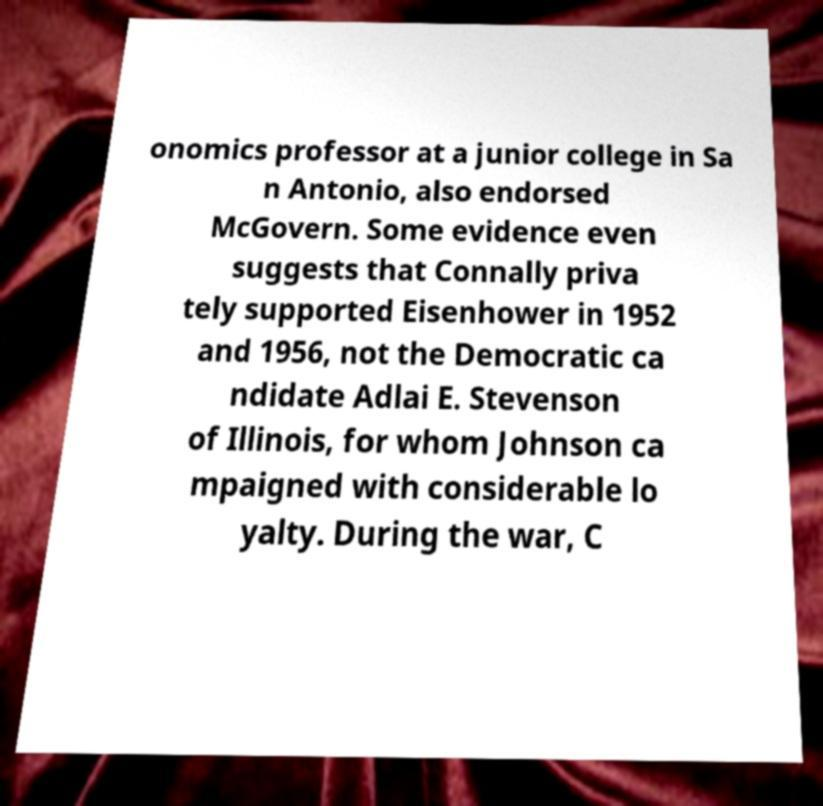Could you extract and type out the text from this image? onomics professor at a junior college in Sa n Antonio, also endorsed McGovern. Some evidence even suggests that Connally priva tely supported Eisenhower in 1952 and 1956, not the Democratic ca ndidate Adlai E. Stevenson of Illinois, for whom Johnson ca mpaigned with considerable lo yalty. During the war, C 